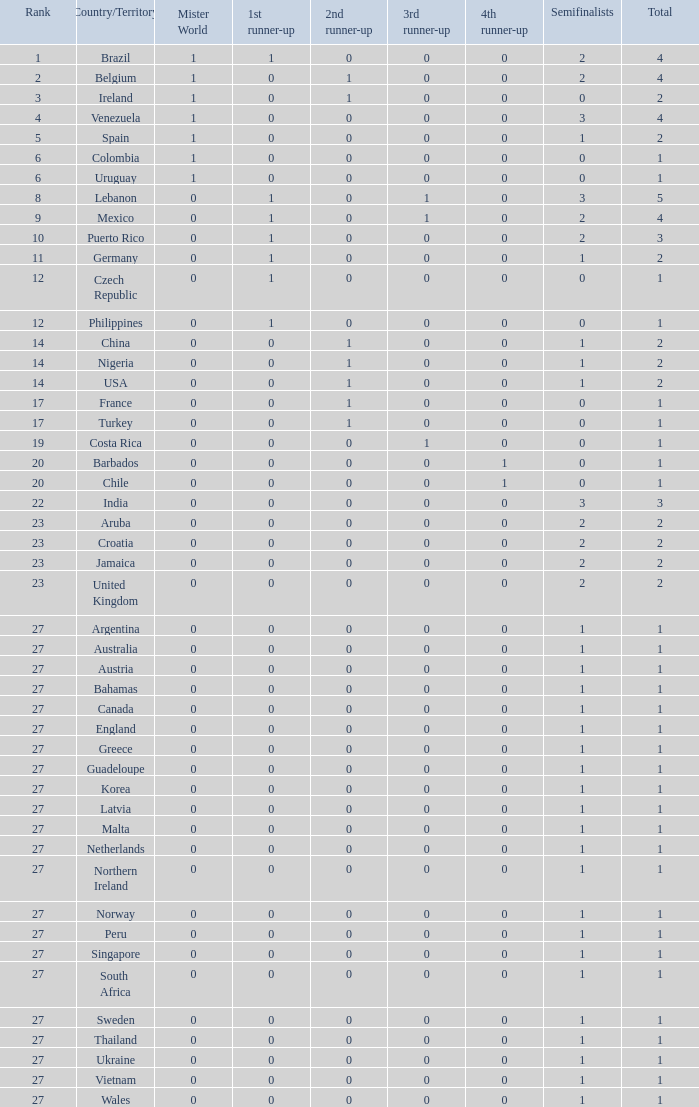What is the quantity of 1st runner up values for jamaica? 1.0. 